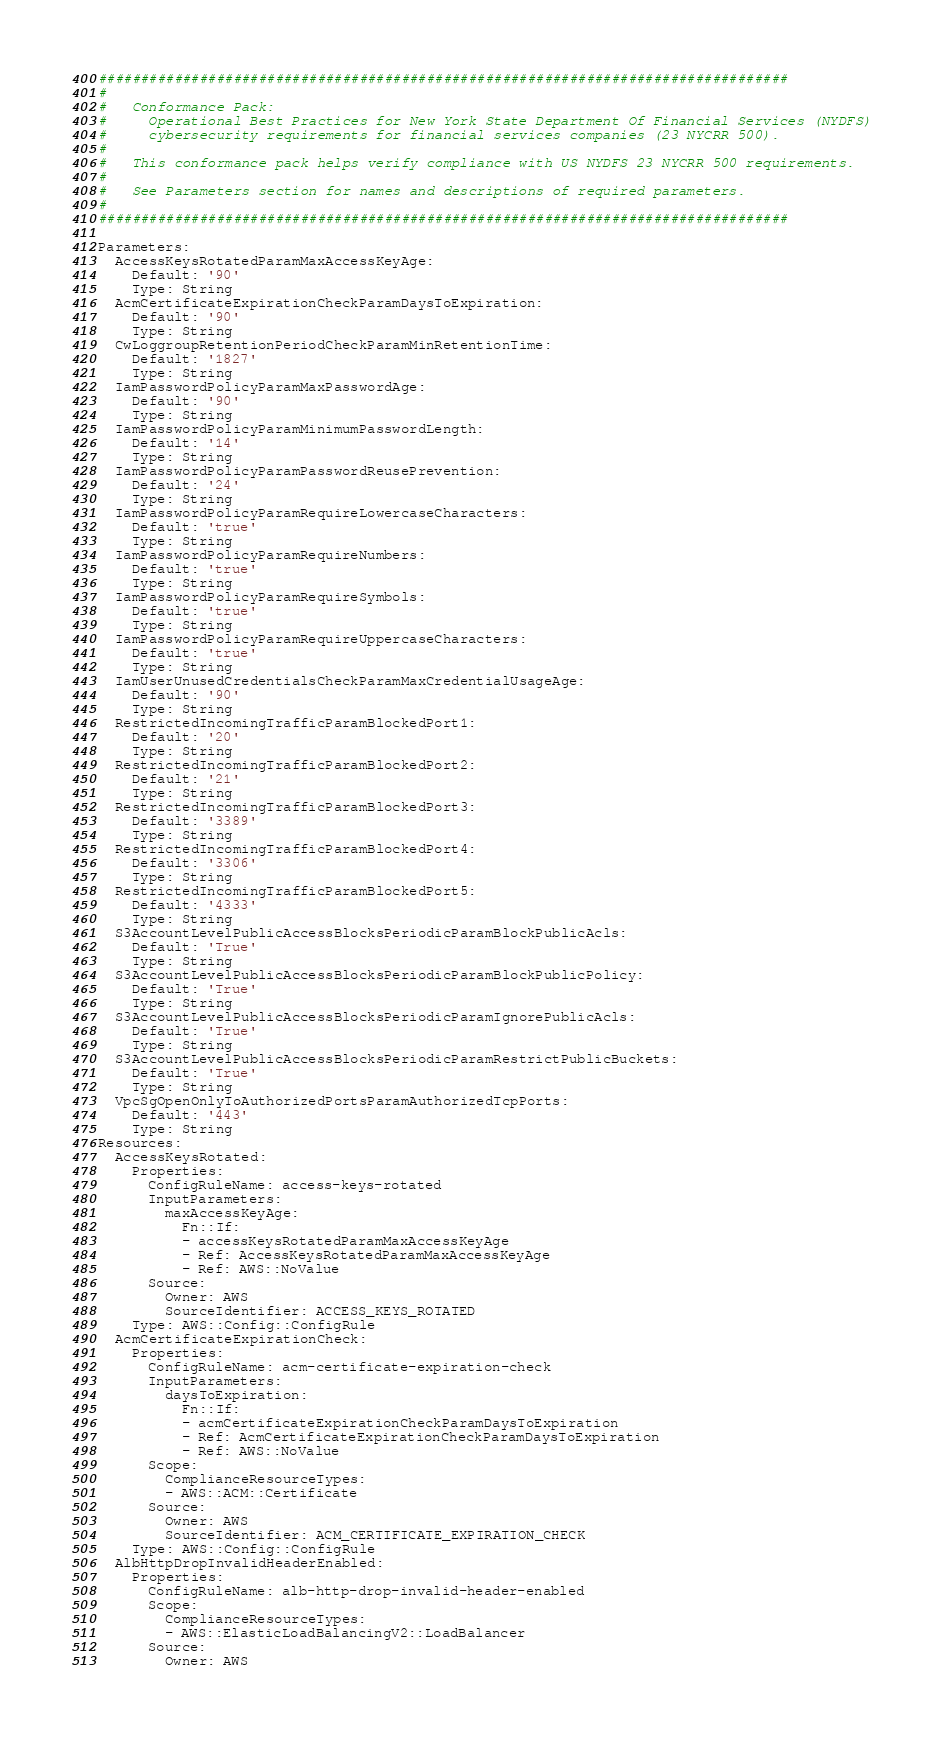Convert code to text. <code><loc_0><loc_0><loc_500><loc_500><_YAML_>##################################################################################
#
#   Conformance Pack:
#     Operational Best Practices for New York State Department Of Financial Services (NYDFS)
#     cybersecurity requirements for financial services companies (23 NYCRR 500).
#
#   This conformance pack helps verify compliance with US NYDFS 23 NYCRR 500 requirements.
#
#   See Parameters section for names and descriptions of required parameters.
#
##################################################################################

Parameters:
  AccessKeysRotatedParamMaxAccessKeyAge:
    Default: '90'
    Type: String
  AcmCertificateExpirationCheckParamDaysToExpiration:
    Default: '90'
    Type: String
  CwLoggroupRetentionPeriodCheckParamMinRetentionTime:
    Default: '1827'
    Type: String
  IamPasswordPolicyParamMaxPasswordAge:
    Default: '90'
    Type: String
  IamPasswordPolicyParamMinimumPasswordLength:
    Default: '14'
    Type: String
  IamPasswordPolicyParamPasswordReusePrevention:
    Default: '24'
    Type: String
  IamPasswordPolicyParamRequireLowercaseCharacters:
    Default: 'true'
    Type: String
  IamPasswordPolicyParamRequireNumbers:
    Default: 'true'
    Type: String
  IamPasswordPolicyParamRequireSymbols:
    Default: 'true'
    Type: String
  IamPasswordPolicyParamRequireUppercaseCharacters:
    Default: 'true'
    Type: String
  IamUserUnusedCredentialsCheckParamMaxCredentialUsageAge:
    Default: '90'
    Type: String
  RestrictedIncomingTrafficParamBlockedPort1:
    Default: '20'
    Type: String
  RestrictedIncomingTrafficParamBlockedPort2:
    Default: '21'
    Type: String
  RestrictedIncomingTrafficParamBlockedPort3:
    Default: '3389'
    Type: String
  RestrictedIncomingTrafficParamBlockedPort4:
    Default: '3306'
    Type: String
  RestrictedIncomingTrafficParamBlockedPort5:
    Default: '4333'
    Type: String
  S3AccountLevelPublicAccessBlocksPeriodicParamBlockPublicAcls:
    Default: 'True'
    Type: String
  S3AccountLevelPublicAccessBlocksPeriodicParamBlockPublicPolicy:
    Default: 'True'
    Type: String
  S3AccountLevelPublicAccessBlocksPeriodicParamIgnorePublicAcls:
    Default: 'True'
    Type: String
  S3AccountLevelPublicAccessBlocksPeriodicParamRestrictPublicBuckets:
    Default: 'True'
    Type: String
  VpcSgOpenOnlyToAuthorizedPortsParamAuthorizedTcpPorts:
    Default: '443'
    Type: String
Resources:
  AccessKeysRotated:
    Properties:
      ConfigRuleName: access-keys-rotated
      InputParameters:
        maxAccessKeyAge:
          Fn::If:
          - accessKeysRotatedParamMaxAccessKeyAge
          - Ref: AccessKeysRotatedParamMaxAccessKeyAge
          - Ref: AWS::NoValue
      Source:
        Owner: AWS
        SourceIdentifier: ACCESS_KEYS_ROTATED
    Type: AWS::Config::ConfigRule
  AcmCertificateExpirationCheck:
    Properties:
      ConfigRuleName: acm-certificate-expiration-check
      InputParameters:
        daysToExpiration:
          Fn::If:
          - acmCertificateExpirationCheckParamDaysToExpiration
          - Ref: AcmCertificateExpirationCheckParamDaysToExpiration
          - Ref: AWS::NoValue
      Scope:
        ComplianceResourceTypes:
        - AWS::ACM::Certificate
      Source:
        Owner: AWS
        SourceIdentifier: ACM_CERTIFICATE_EXPIRATION_CHECK
    Type: AWS::Config::ConfigRule
  AlbHttpDropInvalidHeaderEnabled:
    Properties:
      ConfigRuleName: alb-http-drop-invalid-header-enabled
      Scope:
        ComplianceResourceTypes:
        - AWS::ElasticLoadBalancingV2::LoadBalancer
      Source:
        Owner: AWS</code> 